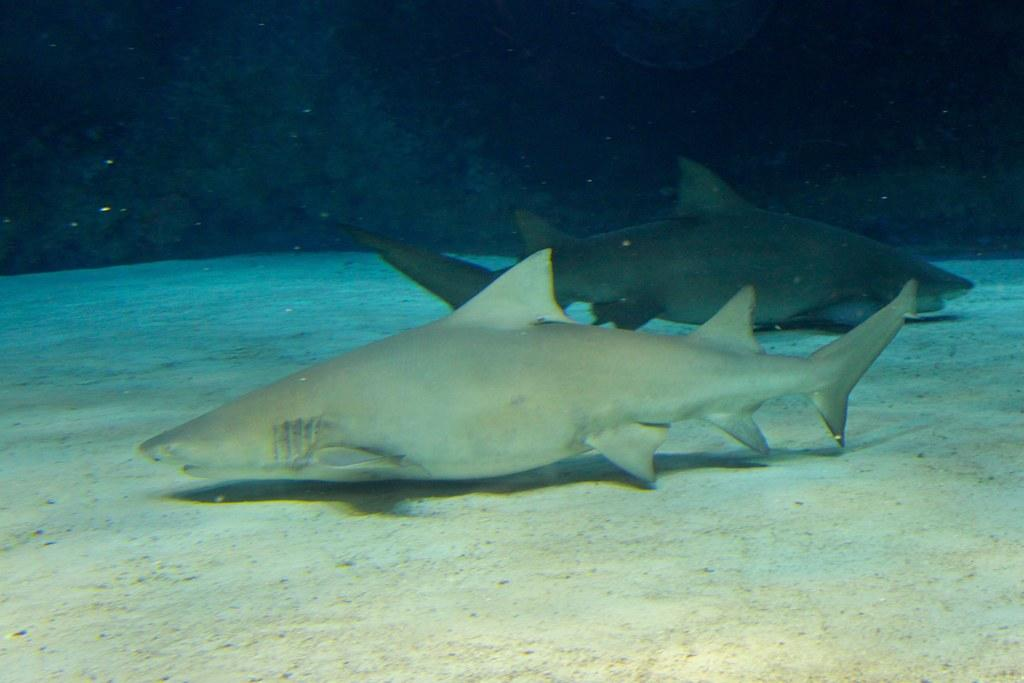How many fish are in the image? There are two fish in the image. What can be observed about the appearance of the fish? The fish are of different colors. What are the fish thinking or desiring in the image? It is impossible to determine the thoughts or desires of the fish in the image, as they are not capable of expressing such emotions. 